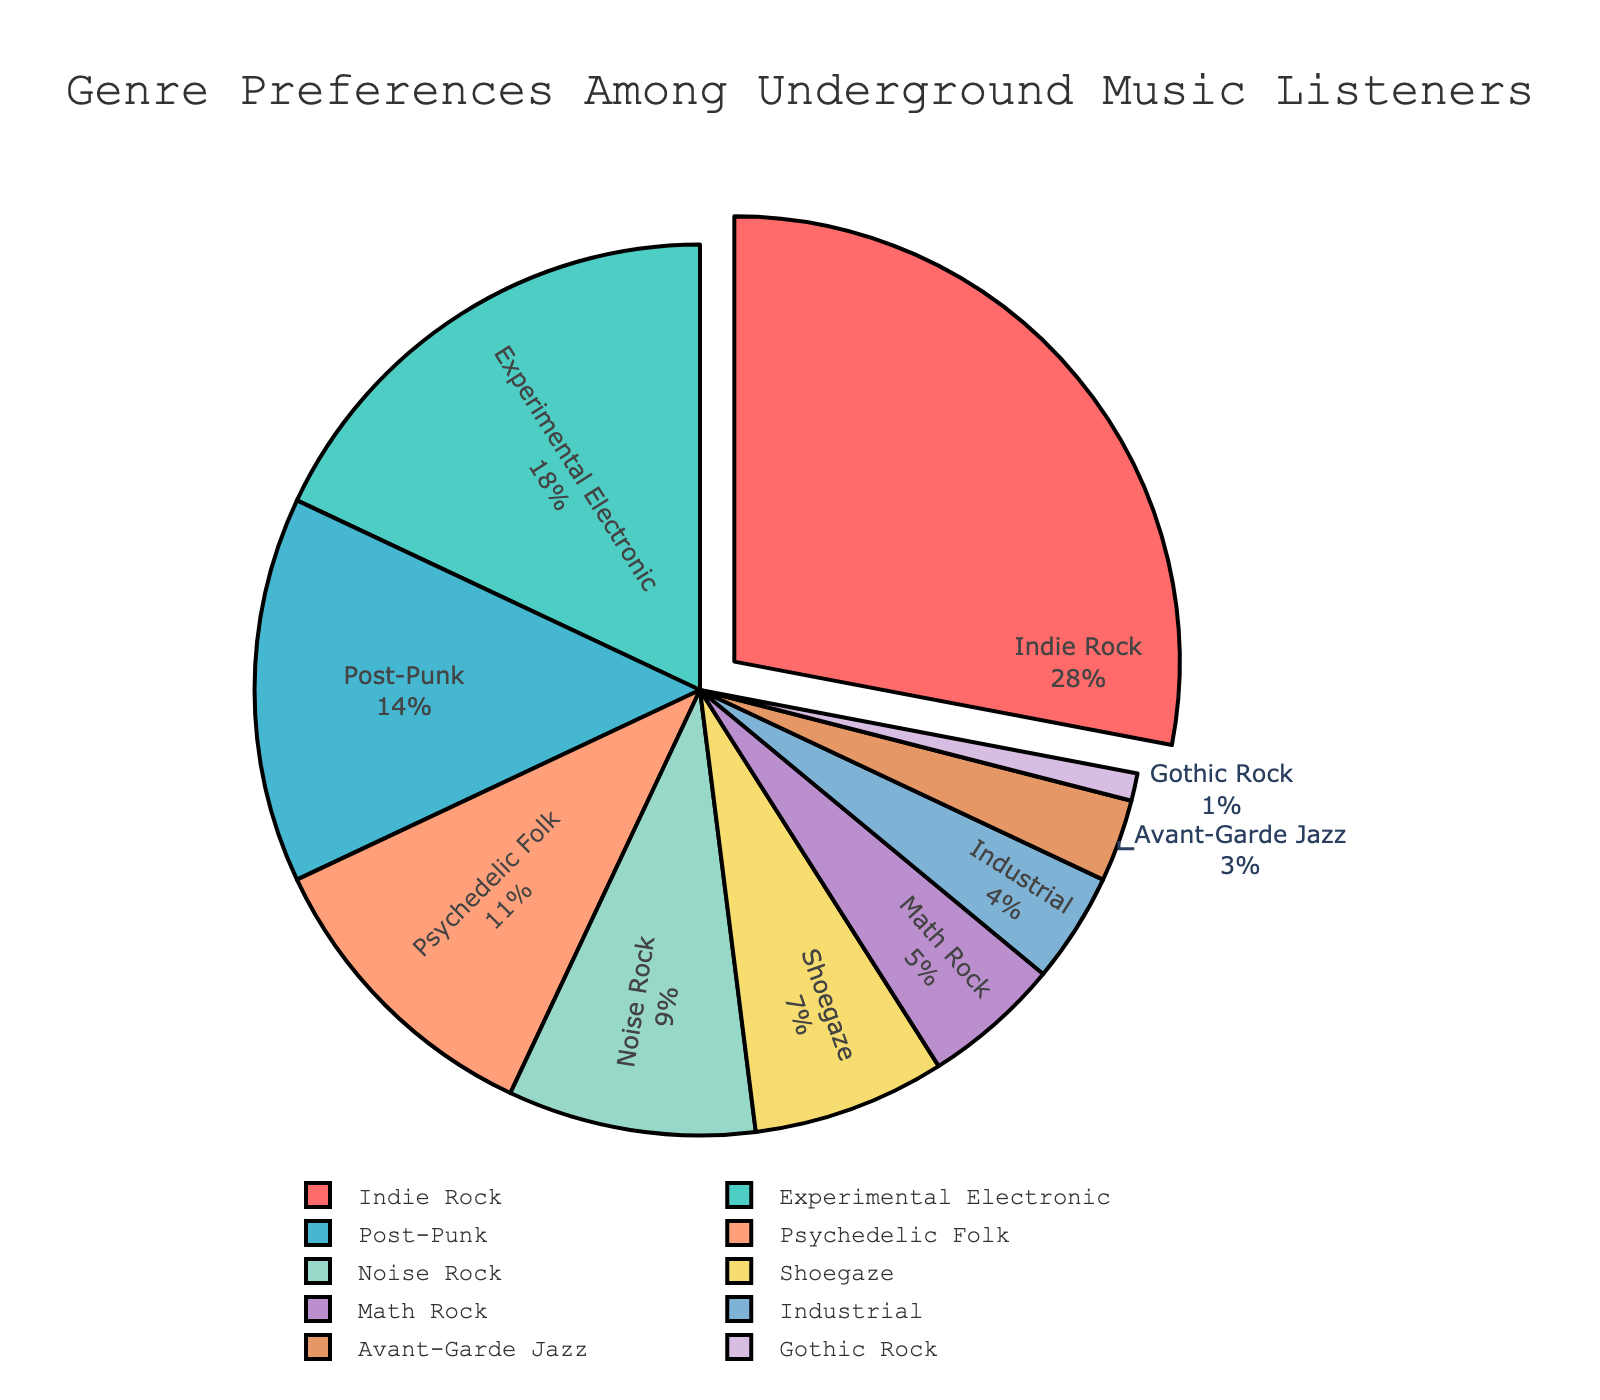What percentage of listeners prefer Indie Rock? The section of the pie chart labeled "Indie Rock" shows 28%, which represents the percentage of listeners who prefer Indie Rock.
Answer: 28% Which genre has the lowest preference among listeners? The smallest section of the pie chart, labeled "Gothic Rock," indicates that it has the lowest preference among listeners, at 1%.
Answer: Gothic Rock What is the total percentage of listeners who prefer either Post-Punk or Psychedelic Folk? Add the percentages of the genres Post-Punk and Psychedelic Folk: 14% + 11% = 25%.
Answer: 25% Which genre has a higher preference: Math Rock or Industrial? The section labeled "Math Rock" shows 5%, while the section labeled "Industrial" shows 4%. Therefore, Math Rock has a higher preference.
Answer: Math Rock How much larger is the percentage of listeners who prefer Indie Rock compared to Experimental Electronic? Subtract the percentage of Experimental Electronic from Indie Rock: 28% - 18% = 10%.
Answer: 10% Are there more listeners who prefer Noise Rock or Shoegaze? The section labeled "Noise Rock" shows 9%, whereas the section labeled "Shoegaze" shows 7%. Thus, more listeners prefer Noise Rock.
Answer: Noise Rock What is the combined percentage of listeners who prefer genres with a preference of 5% or less? Add the percentages of Math Rock, Industrial, Avant-Garde Jazz, and Gothic Rock: 5% + 4% + 3% + 1% = 13%.
Answer: 13% Which genres have a preference of more than 10% but less than 20%? The sections labeled "Experimental Electronic" (18%) and "Post-Punk" (14%) fall in the range of more than 10% but less than 20%.
Answer: Experimental Electronic, Post-Punk What color represents Psychedelic Folk in the pie chart? Observe the slice colored in a distinctive light brown, which corresponds to the genre label "Psychedelic Folk."
Answer: Light brown How many genres have a preference greater than Avant-Garde Jazz but less than Post-Punk? Identify the segments that fall between 3% (Avant-Garde Jazz) and 14% (Post-Punk): Noise Rock (9%), Shoegaze (7%), and Math Rock (5%). Count these genres.
Answer: 3 genres 